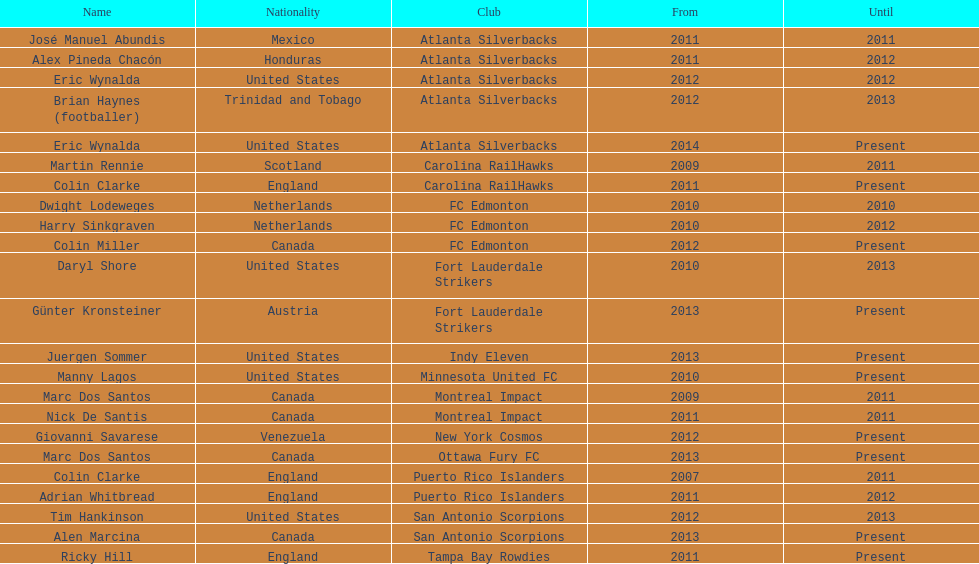What is the number of coaches that have coached from america? 6. 